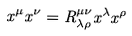Convert formula to latex. <formula><loc_0><loc_0><loc_500><loc_500>x ^ { \mu } x ^ { \nu } = R ^ { \mu \nu } _ { \lambda \rho } x ^ { \lambda } x ^ { \rho }</formula> 